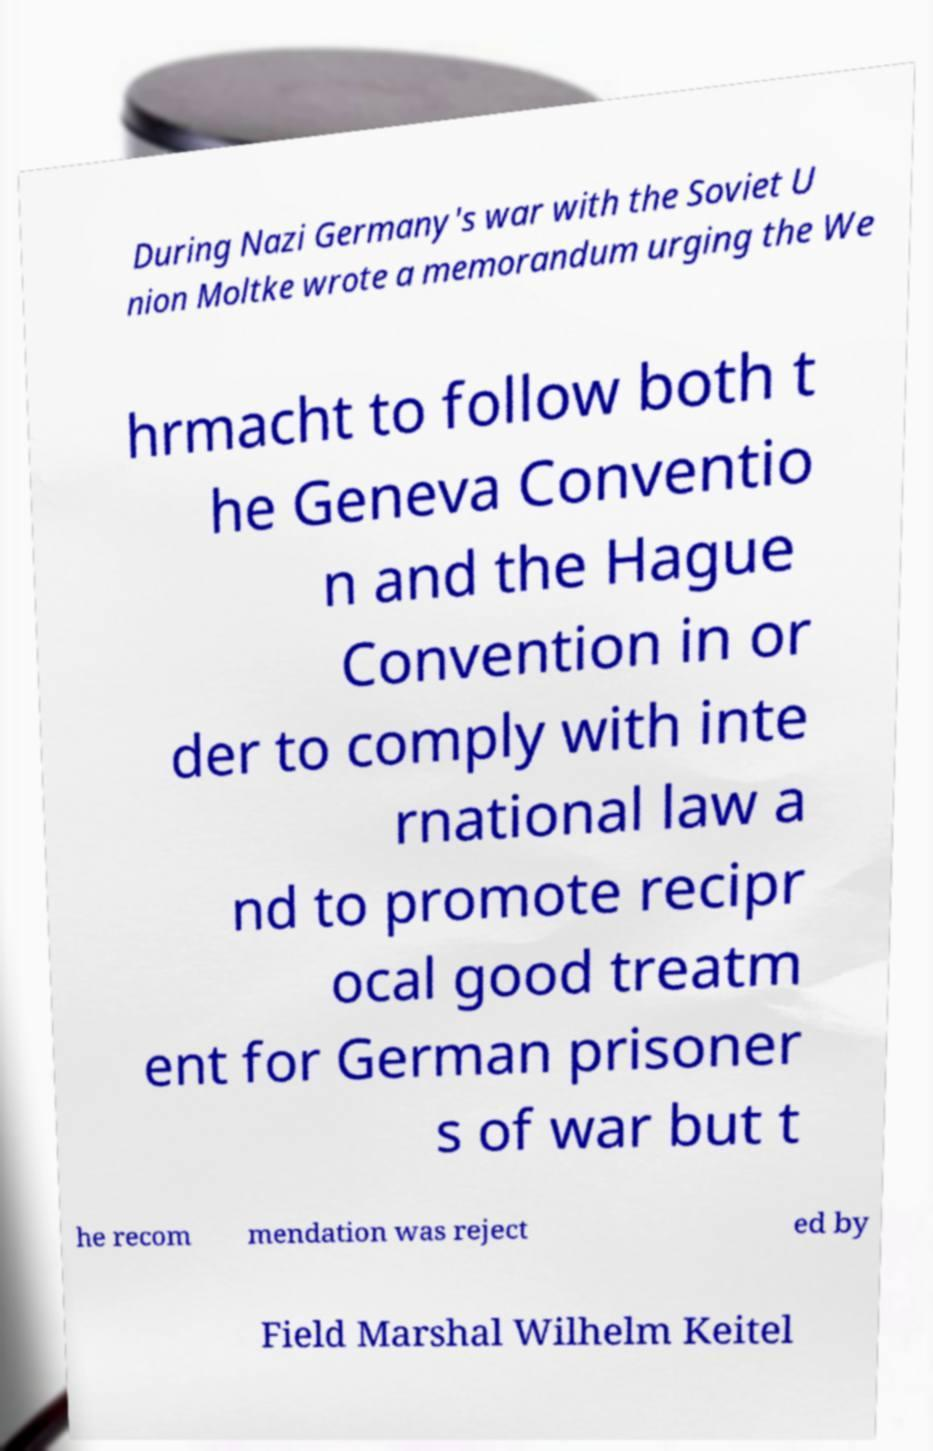Could you assist in decoding the text presented in this image and type it out clearly? During Nazi Germany's war with the Soviet U nion Moltke wrote a memorandum urging the We hrmacht to follow both t he Geneva Conventio n and the Hague Convention in or der to comply with inte rnational law a nd to promote recipr ocal good treatm ent for German prisoner s of war but t he recom mendation was reject ed by Field Marshal Wilhelm Keitel 